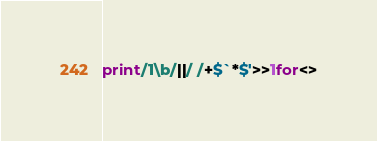<code> <loc_0><loc_0><loc_500><loc_500><_Perl_>print/1\b/||/ /+$`*$'>>1for<></code> 